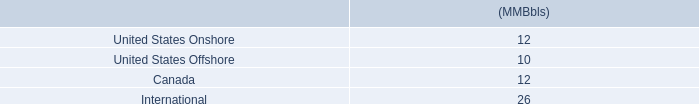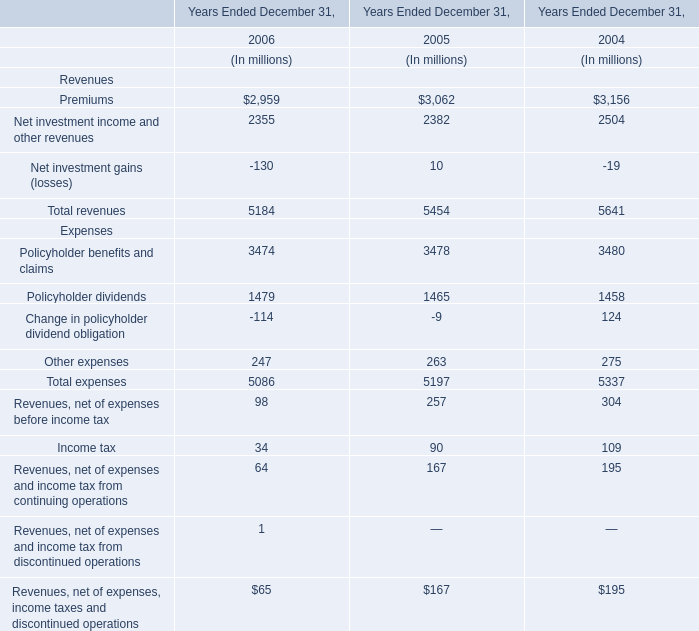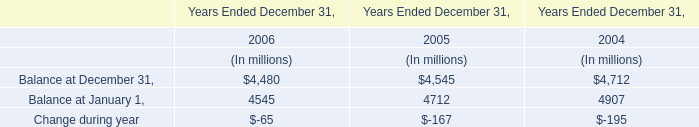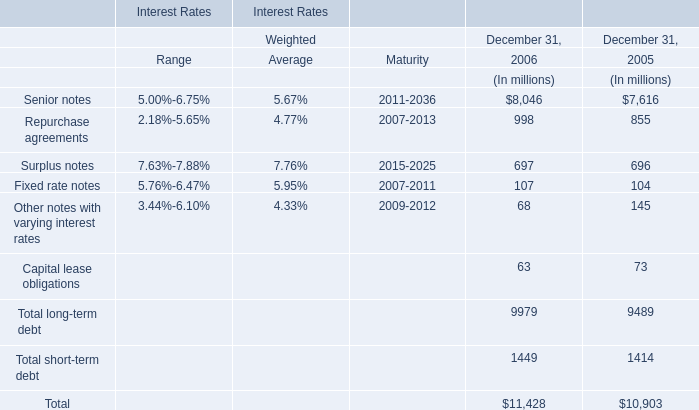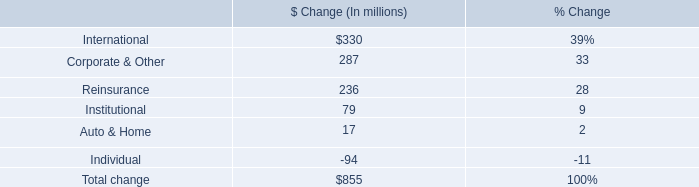What was the total amount of Surplus notes in 2006 and 2005、 (in million) 
Computations: (697 + 696)
Answer: 1393.0. 